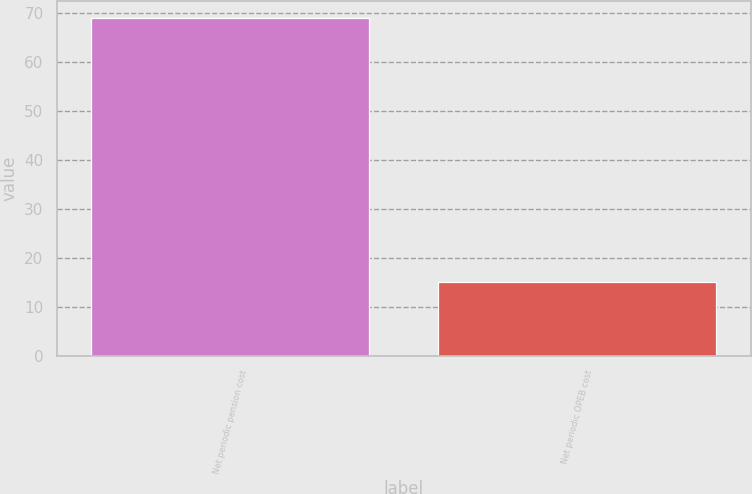<chart> <loc_0><loc_0><loc_500><loc_500><bar_chart><fcel>Net periodic pension cost<fcel>Net periodic OPEB cost<nl><fcel>69<fcel>15<nl></chart> 